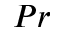<formula> <loc_0><loc_0><loc_500><loc_500>P r</formula> 